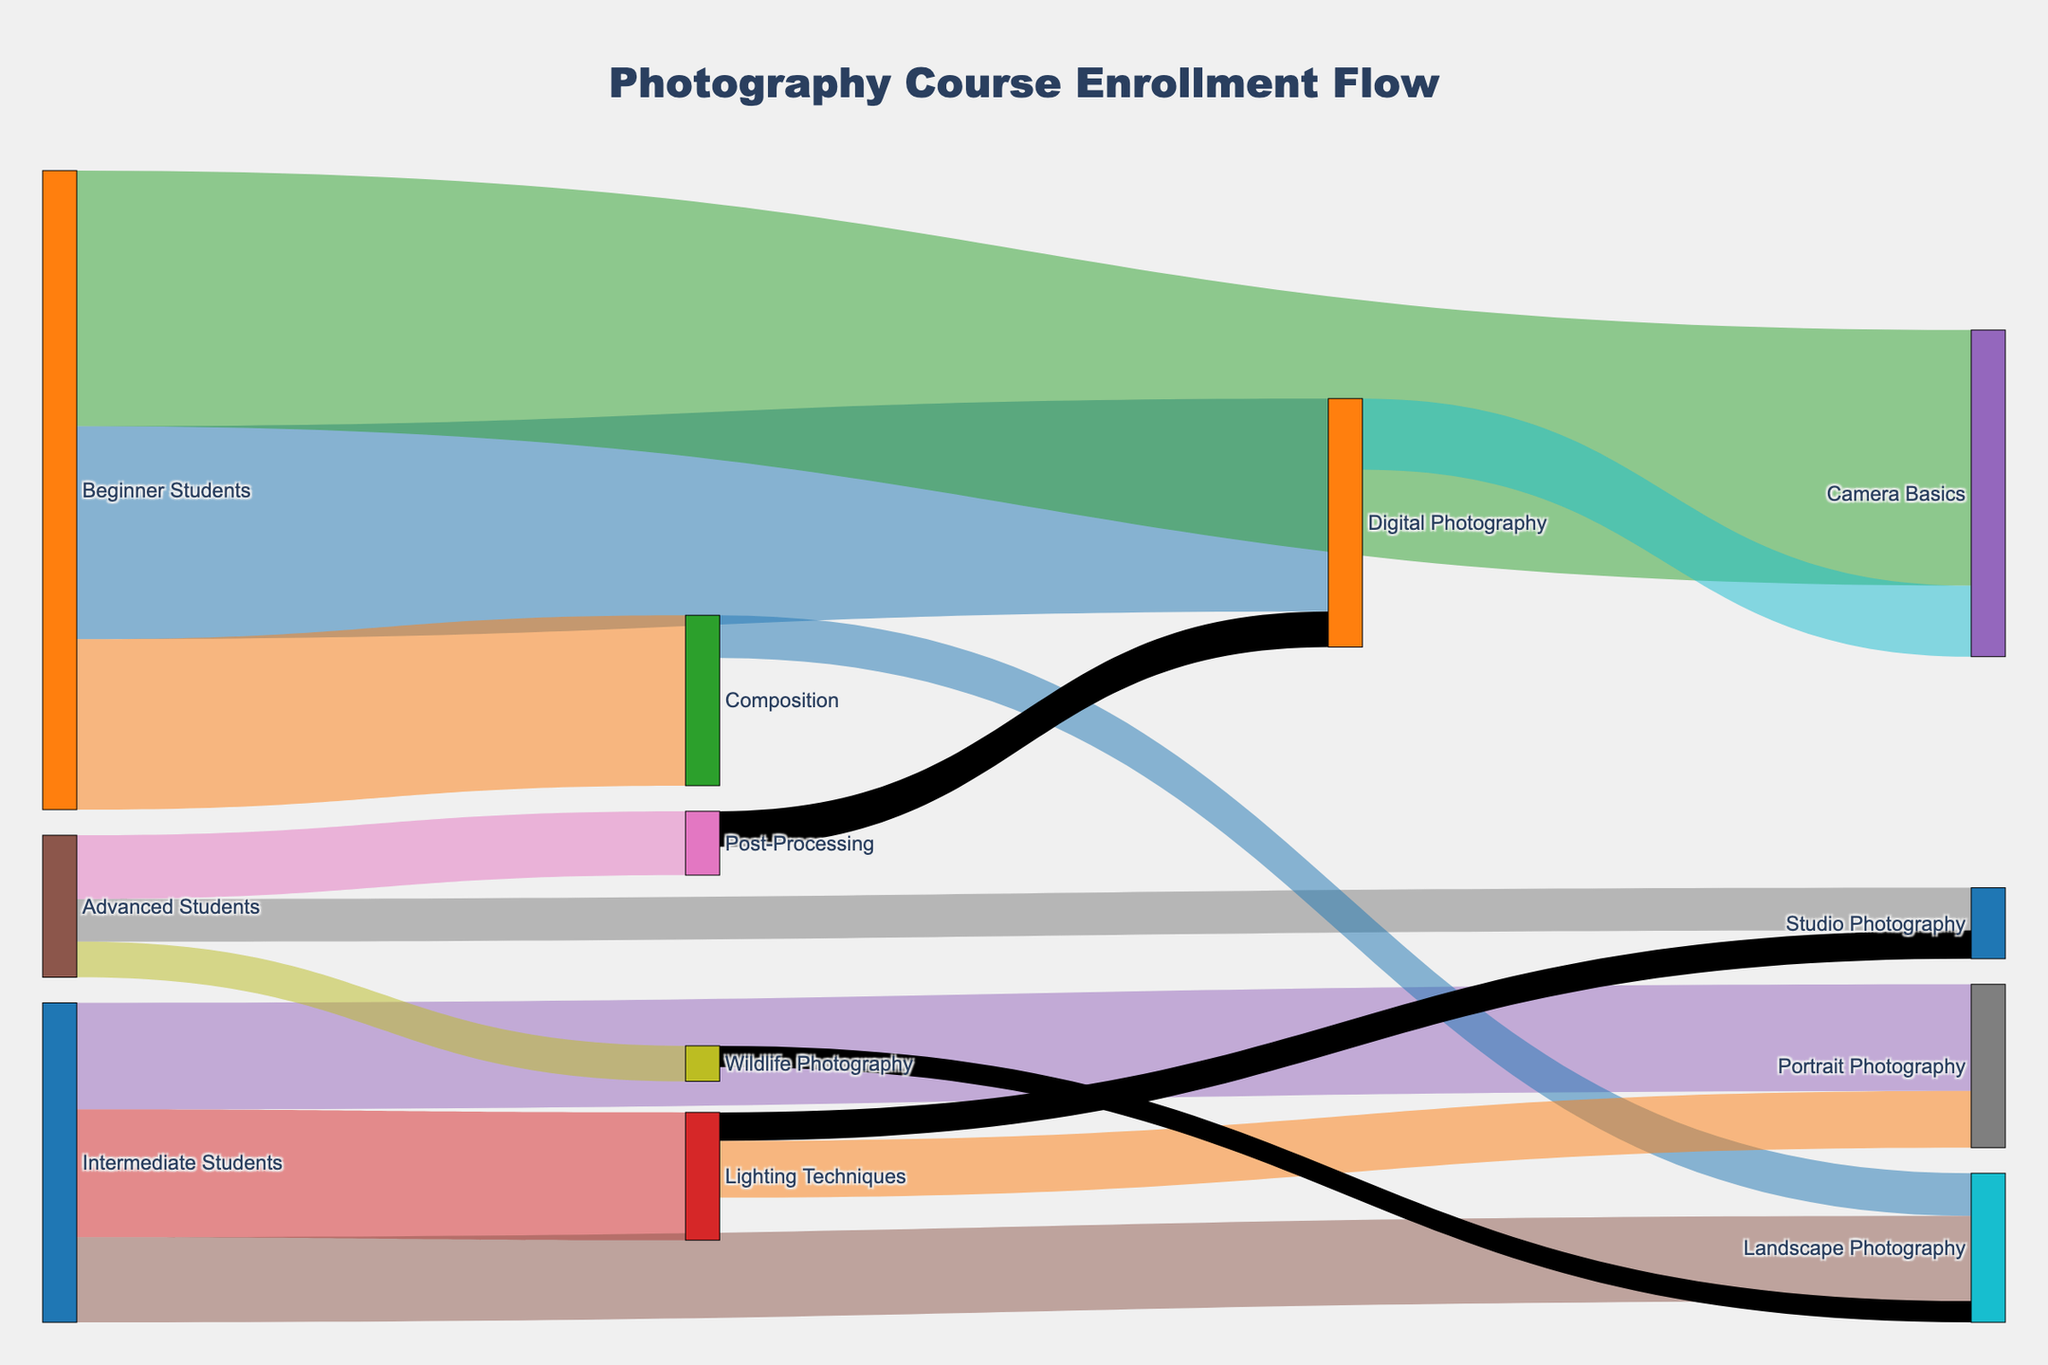How many beginner students enrolled in Camera Basics? Look at the Sankey diagram, specifically at the link from "Beginner Students" to "Camera Basics". The value indicates the number of enrollments.
Answer: 180 What is the total number of students enrolled in Digital Photography considering all skill levels? Add up the values of the links to "Digital Photography" from all skill levels ("Beginner Students" and "Post-Processing"). The values are 150 and 25, respectively. Therefore, the total is 150 + 25 = 175.
Answer: 175 Which skill level has the fewest students enrolled in Portrait Photography? Compare the values of the links to "Portrait Photography" from different skill levels. The values are 75 (Intermediate Students) and 40 (Lighting Techniques). "Lighting Techniques" link is less than "Intermediate Students" link.
Answer: Lighting Techniques How many students advanced from Composition to Landscape Photography? Look at the link between "Composition" and "Landscape Photography". The value indicates the number of students who advanced.
Answer: 30 Which subject has the highest enrollment from beginner students? Compare the values of links from "Beginner Students" to different subjects (Camera Basics, Composition, Digital Photography). The highest value is 180 for Camera Basics.
Answer: Camera Basics What is the total number of students enrolled in all advanced-level subjects? Add up the values of links from "Advanced Students" to each advanced-level subject. The values are 45 (Post-Processing), 30 (Studio Photography), and 25 (Wildlife Photography), resulting in a total of 45 + 30 + 25 = 100.
Answer: 100 How many students from Lighting Techniques enrolled in Studio Photography? Look at the link between "Lighting Techniques" and "Studio Photography". The value indicates the number of students.
Answer: 20 Which subject has more students: Landscape Photography or Wildlife Photography? Compare the total enrollments in "Landscape Photography" and "Wildlife Photography". "Landscape Photography" has 60 (Intermediate Students) + 30 (Composition) + 15 (Wildlife Photography) = 105. "Wildlife Photography" has 25 (Advanced Students) = 25. Thus, Landscape Photography has more students.
Answer: Landscape Photography How many students moved from Wildlife Photography to Landscape Photography? Look at the link between "Wildlife Photography" and "Landscape Photography". The value indicates the number of students.
Answer: 15 